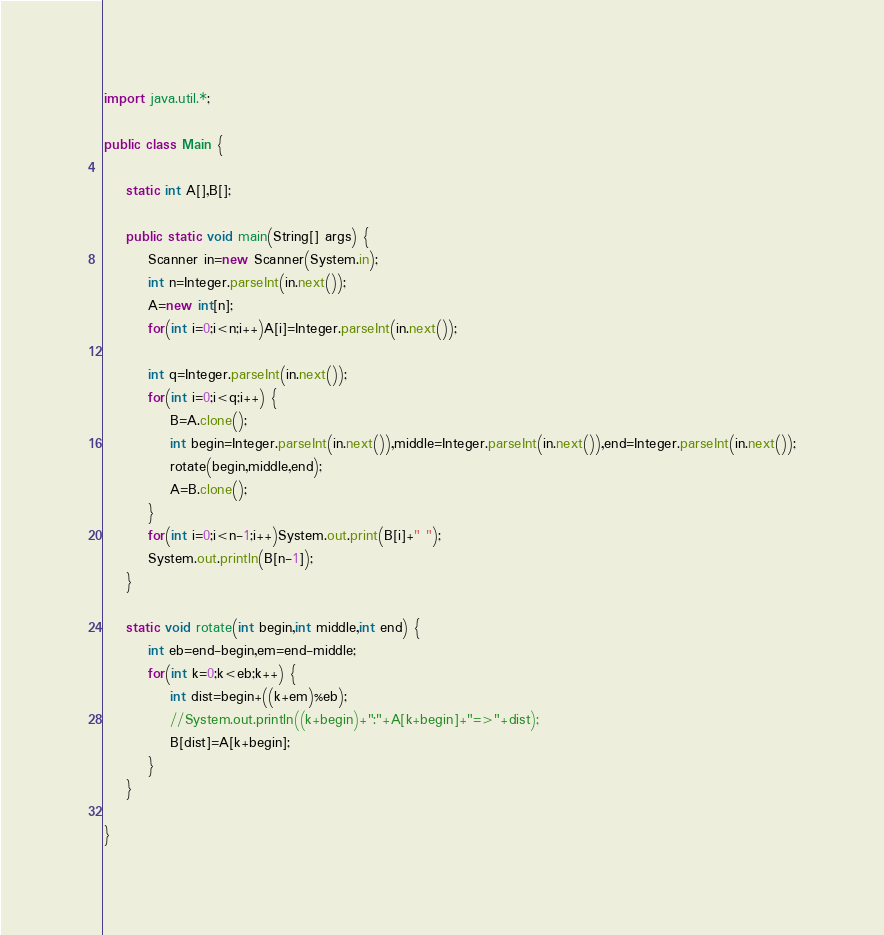<code> <loc_0><loc_0><loc_500><loc_500><_Java_>import java.util.*;

public class Main {
	
	static int A[],B[];
	
	public static void main(String[] args) {
		Scanner in=new Scanner(System.in);
		int n=Integer.parseInt(in.next());
		A=new int[n];
		for(int i=0;i<n;i++)A[i]=Integer.parseInt(in.next());
		
		int q=Integer.parseInt(in.next());
		for(int i=0;i<q;i++) {
			B=A.clone();
			int begin=Integer.parseInt(in.next()),middle=Integer.parseInt(in.next()),end=Integer.parseInt(in.next());
			rotate(begin,middle,end);
			A=B.clone();
		}
		for(int i=0;i<n-1;i++)System.out.print(B[i]+" ");
		System.out.println(B[n-1]);
	}
	
	static void rotate(int begin,int middle,int end) {
		int eb=end-begin,em=end-middle;
		for(int k=0;k<eb;k++) {
			int dist=begin+((k+em)%eb);
			//System.out.println((k+begin)+":"+A[k+begin]+"=>"+dist);
			B[dist]=A[k+begin];
		}
	}

}

</code> 